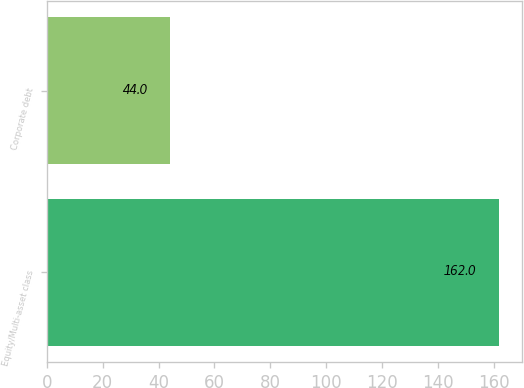Convert chart. <chart><loc_0><loc_0><loc_500><loc_500><bar_chart><fcel>Equity/Multi-asset class<fcel>Corporate debt<nl><fcel>162<fcel>44<nl></chart> 